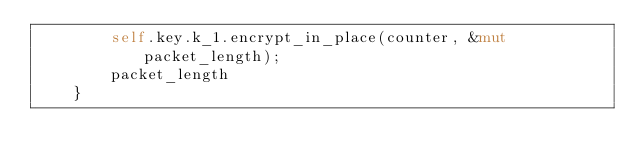Convert code to text. <code><loc_0><loc_0><loc_500><loc_500><_Rust_>        self.key.k_1.encrypt_in_place(counter, &mut packet_length);
        packet_length
    }
</code> 